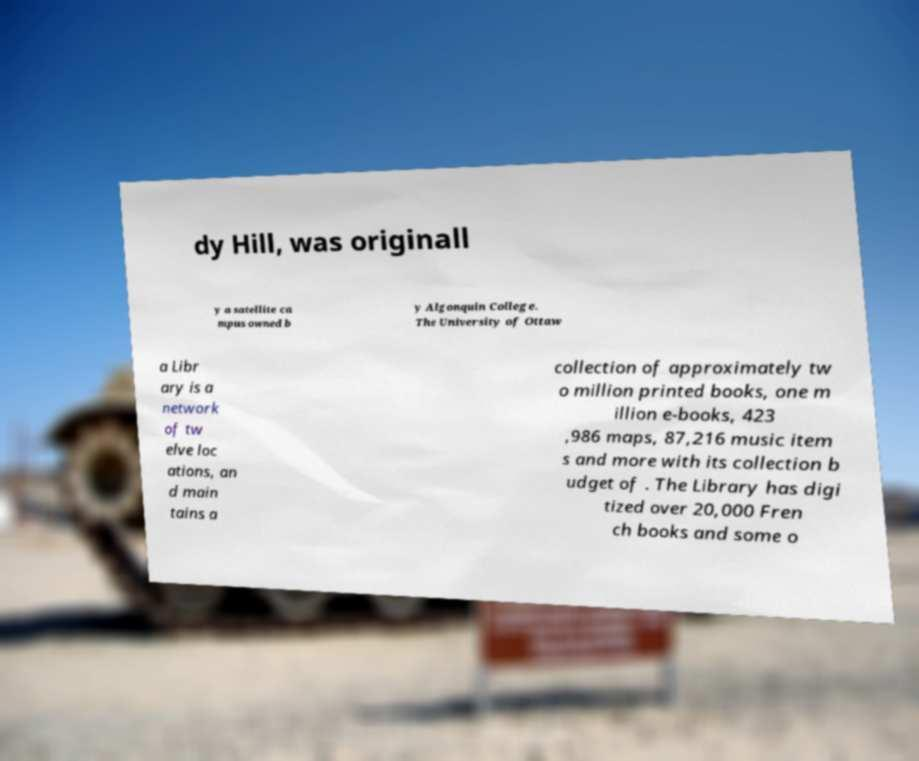For documentation purposes, I need the text within this image transcribed. Could you provide that? dy Hill, was originall y a satellite ca mpus owned b y Algonquin College. The University of Ottaw a Libr ary is a network of tw elve loc ations, an d main tains a collection of approximately tw o million printed books, one m illion e-books, 423 ,986 maps, 87,216 music item s and more with its collection b udget of . The Library has digi tized over 20,000 Fren ch books and some o 